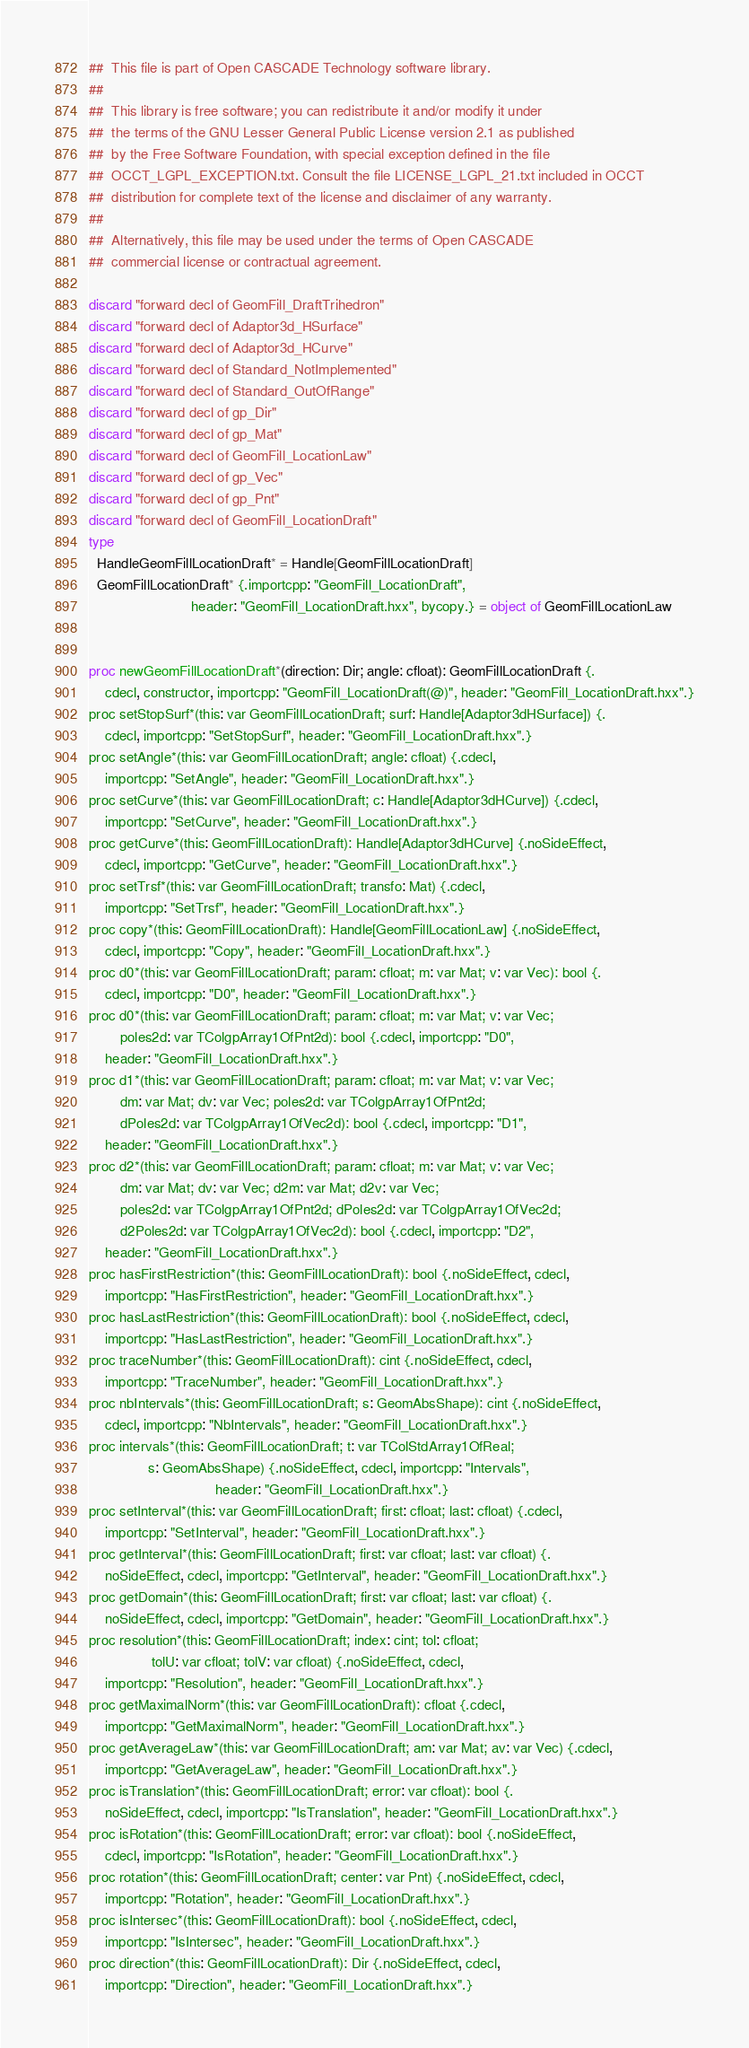<code> <loc_0><loc_0><loc_500><loc_500><_Nim_>##  This file is part of Open CASCADE Technology software library.
##
##  This library is free software; you can redistribute it and/or modify it under
##  the terms of the GNU Lesser General Public License version 2.1 as published
##  by the Free Software Foundation, with special exception defined in the file
##  OCCT_LGPL_EXCEPTION.txt. Consult the file LICENSE_LGPL_21.txt included in OCCT
##  distribution for complete text of the license and disclaimer of any warranty.
##
##  Alternatively, this file may be used under the terms of Open CASCADE
##  commercial license or contractual agreement.

discard "forward decl of GeomFill_DraftTrihedron"
discard "forward decl of Adaptor3d_HSurface"
discard "forward decl of Adaptor3d_HCurve"
discard "forward decl of Standard_NotImplemented"
discard "forward decl of Standard_OutOfRange"
discard "forward decl of gp_Dir"
discard "forward decl of gp_Mat"
discard "forward decl of GeomFill_LocationLaw"
discard "forward decl of gp_Vec"
discard "forward decl of gp_Pnt"
discard "forward decl of GeomFill_LocationDraft"
type
  HandleGeomFillLocationDraft* = Handle[GeomFillLocationDraft]
  GeomFillLocationDraft* {.importcpp: "GeomFill_LocationDraft",
                          header: "GeomFill_LocationDraft.hxx", bycopy.} = object of GeomFillLocationLaw


proc newGeomFillLocationDraft*(direction: Dir; angle: cfloat): GeomFillLocationDraft {.
    cdecl, constructor, importcpp: "GeomFill_LocationDraft(@)", header: "GeomFill_LocationDraft.hxx".}
proc setStopSurf*(this: var GeomFillLocationDraft; surf: Handle[Adaptor3dHSurface]) {.
    cdecl, importcpp: "SetStopSurf", header: "GeomFill_LocationDraft.hxx".}
proc setAngle*(this: var GeomFillLocationDraft; angle: cfloat) {.cdecl,
    importcpp: "SetAngle", header: "GeomFill_LocationDraft.hxx".}
proc setCurve*(this: var GeomFillLocationDraft; c: Handle[Adaptor3dHCurve]) {.cdecl,
    importcpp: "SetCurve", header: "GeomFill_LocationDraft.hxx".}
proc getCurve*(this: GeomFillLocationDraft): Handle[Adaptor3dHCurve] {.noSideEffect,
    cdecl, importcpp: "GetCurve", header: "GeomFill_LocationDraft.hxx".}
proc setTrsf*(this: var GeomFillLocationDraft; transfo: Mat) {.cdecl,
    importcpp: "SetTrsf", header: "GeomFill_LocationDraft.hxx".}
proc copy*(this: GeomFillLocationDraft): Handle[GeomFillLocationLaw] {.noSideEffect,
    cdecl, importcpp: "Copy", header: "GeomFill_LocationDraft.hxx".}
proc d0*(this: var GeomFillLocationDraft; param: cfloat; m: var Mat; v: var Vec): bool {.
    cdecl, importcpp: "D0", header: "GeomFill_LocationDraft.hxx".}
proc d0*(this: var GeomFillLocationDraft; param: cfloat; m: var Mat; v: var Vec;
        poles2d: var TColgpArray1OfPnt2d): bool {.cdecl, importcpp: "D0",
    header: "GeomFill_LocationDraft.hxx".}
proc d1*(this: var GeomFillLocationDraft; param: cfloat; m: var Mat; v: var Vec;
        dm: var Mat; dv: var Vec; poles2d: var TColgpArray1OfPnt2d;
        dPoles2d: var TColgpArray1OfVec2d): bool {.cdecl, importcpp: "D1",
    header: "GeomFill_LocationDraft.hxx".}
proc d2*(this: var GeomFillLocationDraft; param: cfloat; m: var Mat; v: var Vec;
        dm: var Mat; dv: var Vec; d2m: var Mat; d2v: var Vec;
        poles2d: var TColgpArray1OfPnt2d; dPoles2d: var TColgpArray1OfVec2d;
        d2Poles2d: var TColgpArray1OfVec2d): bool {.cdecl, importcpp: "D2",
    header: "GeomFill_LocationDraft.hxx".}
proc hasFirstRestriction*(this: GeomFillLocationDraft): bool {.noSideEffect, cdecl,
    importcpp: "HasFirstRestriction", header: "GeomFill_LocationDraft.hxx".}
proc hasLastRestriction*(this: GeomFillLocationDraft): bool {.noSideEffect, cdecl,
    importcpp: "HasLastRestriction", header: "GeomFill_LocationDraft.hxx".}
proc traceNumber*(this: GeomFillLocationDraft): cint {.noSideEffect, cdecl,
    importcpp: "TraceNumber", header: "GeomFill_LocationDraft.hxx".}
proc nbIntervals*(this: GeomFillLocationDraft; s: GeomAbsShape): cint {.noSideEffect,
    cdecl, importcpp: "NbIntervals", header: "GeomFill_LocationDraft.hxx".}
proc intervals*(this: GeomFillLocationDraft; t: var TColStdArray1OfReal;
               s: GeomAbsShape) {.noSideEffect, cdecl, importcpp: "Intervals",
                                header: "GeomFill_LocationDraft.hxx".}
proc setInterval*(this: var GeomFillLocationDraft; first: cfloat; last: cfloat) {.cdecl,
    importcpp: "SetInterval", header: "GeomFill_LocationDraft.hxx".}
proc getInterval*(this: GeomFillLocationDraft; first: var cfloat; last: var cfloat) {.
    noSideEffect, cdecl, importcpp: "GetInterval", header: "GeomFill_LocationDraft.hxx".}
proc getDomain*(this: GeomFillLocationDraft; first: var cfloat; last: var cfloat) {.
    noSideEffect, cdecl, importcpp: "GetDomain", header: "GeomFill_LocationDraft.hxx".}
proc resolution*(this: GeomFillLocationDraft; index: cint; tol: cfloat;
                tolU: var cfloat; tolV: var cfloat) {.noSideEffect, cdecl,
    importcpp: "Resolution", header: "GeomFill_LocationDraft.hxx".}
proc getMaximalNorm*(this: var GeomFillLocationDraft): cfloat {.cdecl,
    importcpp: "GetMaximalNorm", header: "GeomFill_LocationDraft.hxx".}
proc getAverageLaw*(this: var GeomFillLocationDraft; am: var Mat; av: var Vec) {.cdecl,
    importcpp: "GetAverageLaw", header: "GeomFill_LocationDraft.hxx".}
proc isTranslation*(this: GeomFillLocationDraft; error: var cfloat): bool {.
    noSideEffect, cdecl, importcpp: "IsTranslation", header: "GeomFill_LocationDraft.hxx".}
proc isRotation*(this: GeomFillLocationDraft; error: var cfloat): bool {.noSideEffect,
    cdecl, importcpp: "IsRotation", header: "GeomFill_LocationDraft.hxx".}
proc rotation*(this: GeomFillLocationDraft; center: var Pnt) {.noSideEffect, cdecl,
    importcpp: "Rotation", header: "GeomFill_LocationDraft.hxx".}
proc isIntersec*(this: GeomFillLocationDraft): bool {.noSideEffect, cdecl,
    importcpp: "IsIntersec", header: "GeomFill_LocationDraft.hxx".}
proc direction*(this: GeomFillLocationDraft): Dir {.noSideEffect, cdecl,
    importcpp: "Direction", header: "GeomFill_LocationDraft.hxx".}</code> 